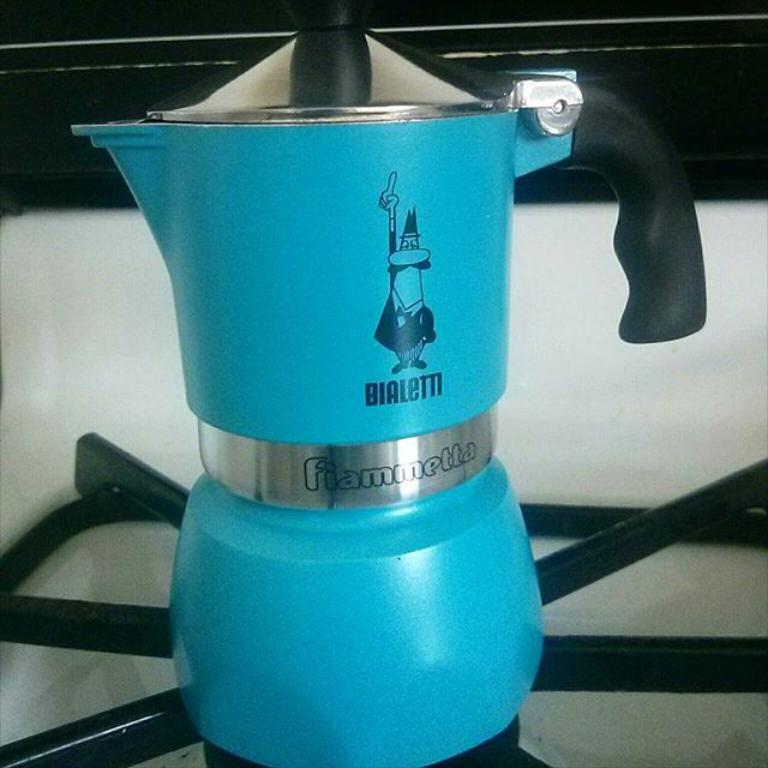<image>
Provide a brief description of the given image. The "Bialetti" man is painted on the Fiammetta Espresso maker. 